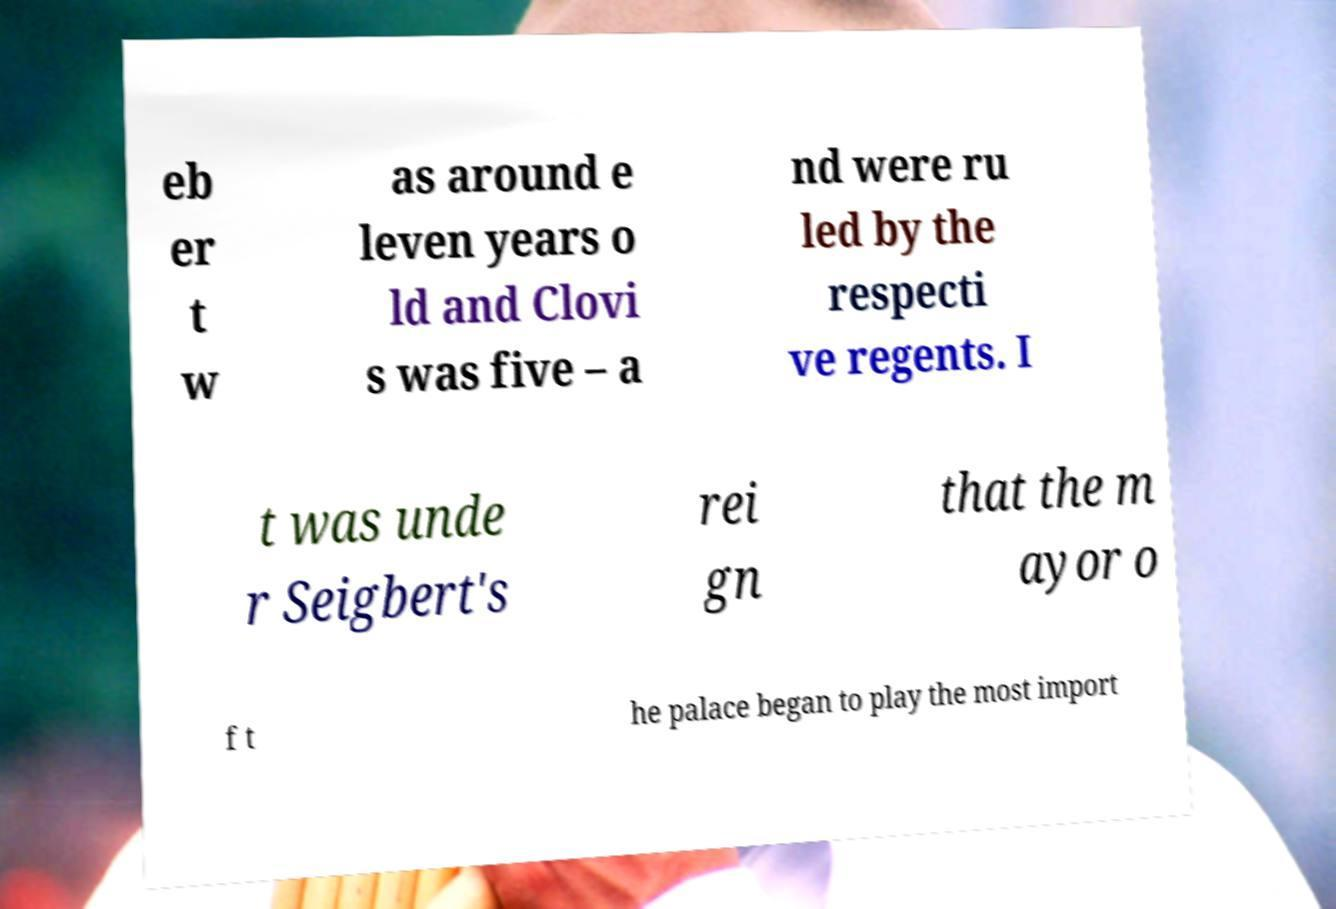Can you read and provide the text displayed in the image?This photo seems to have some interesting text. Can you extract and type it out for me? eb er t w as around e leven years o ld and Clovi s was five – a nd were ru led by the respecti ve regents. I t was unde r Seigbert's rei gn that the m ayor o f t he palace began to play the most import 